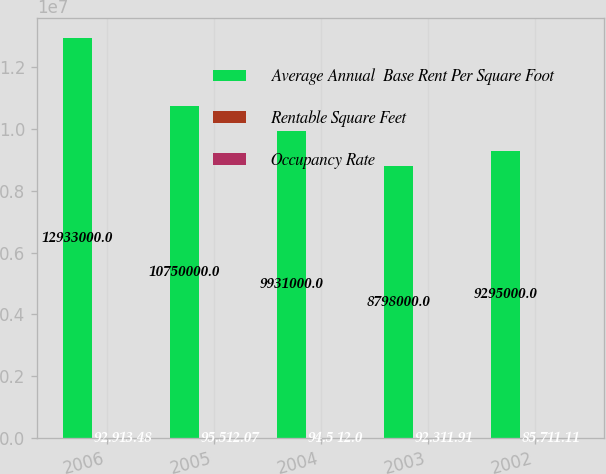Convert chart. <chart><loc_0><loc_0><loc_500><loc_500><stacked_bar_chart><ecel><fcel>2006<fcel>2005<fcel>2004<fcel>2003<fcel>2002<nl><fcel>Average Annual  Base Rent Per Square Foot<fcel>1.2933e+07<fcel>1.075e+07<fcel>9.931e+06<fcel>8.798e+06<fcel>9.295e+06<nl><fcel>Rentable Square Feet<fcel>92.9<fcel>95.5<fcel>94.5<fcel>92.3<fcel>85.7<nl><fcel>Occupancy Rate<fcel>13.48<fcel>12.07<fcel>12<fcel>11.91<fcel>11.11<nl></chart> 